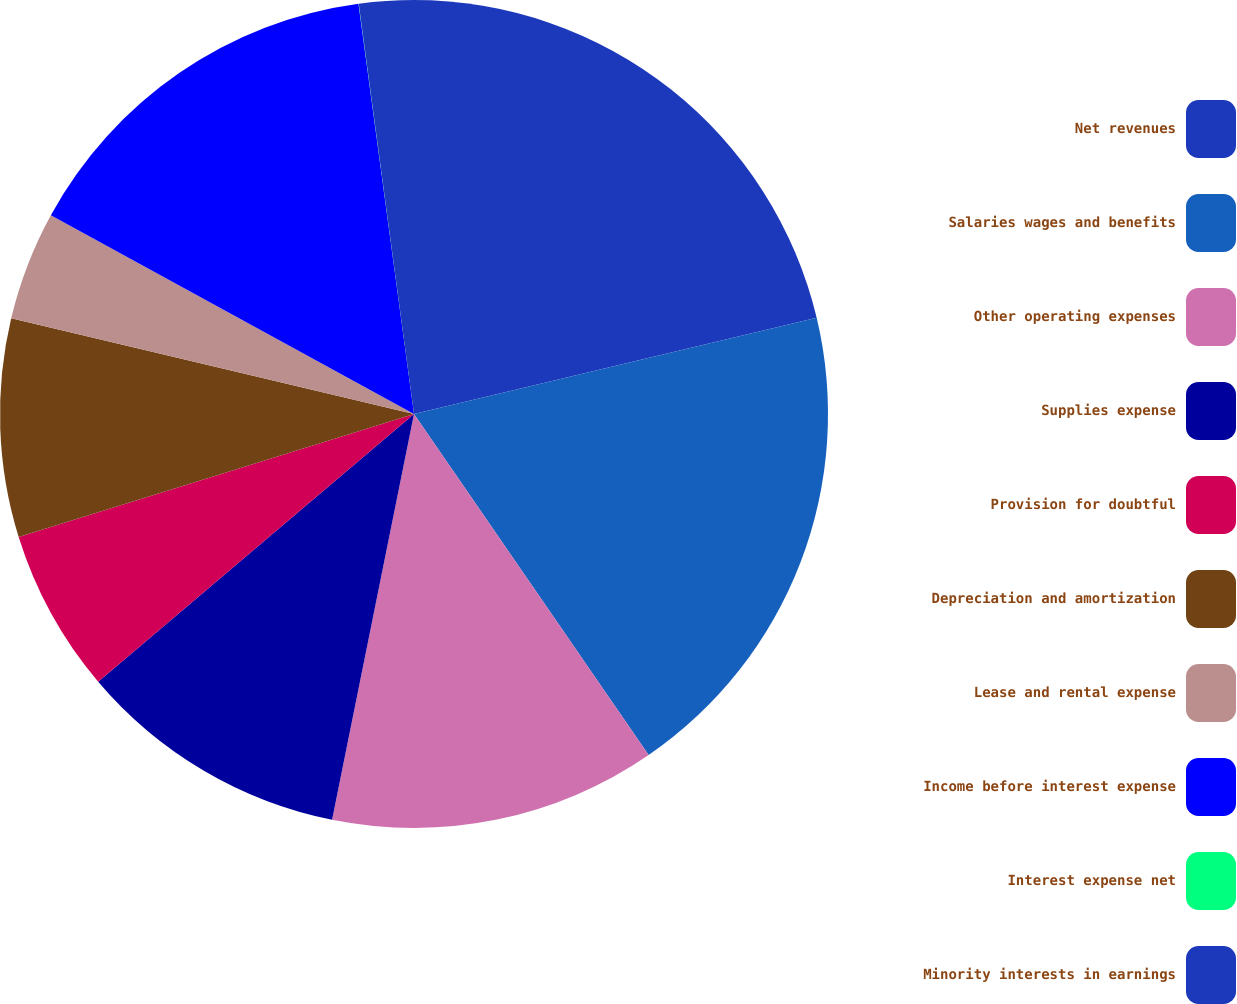Convert chart to OTSL. <chart><loc_0><loc_0><loc_500><loc_500><pie_chart><fcel>Net revenues<fcel>Salaries wages and benefits<fcel>Other operating expenses<fcel>Supplies expense<fcel>Provision for doubtful<fcel>Depreciation and amortization<fcel>Lease and rental expense<fcel>Income before interest expense<fcel>Interest expense net<fcel>Minority interests in earnings<nl><fcel>21.27%<fcel>19.14%<fcel>12.76%<fcel>10.64%<fcel>6.39%<fcel>8.51%<fcel>4.26%<fcel>14.89%<fcel>0.01%<fcel>2.13%<nl></chart> 